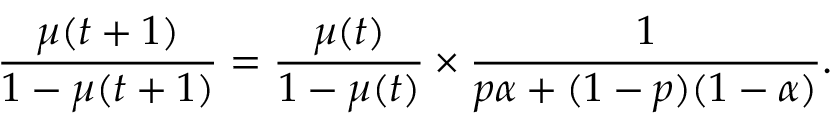<formula> <loc_0><loc_0><loc_500><loc_500>\frac { \mu ( t + 1 ) } { 1 - \mu ( t + 1 ) } = \frac { \mu ( t ) } { 1 - \mu ( t ) } \times \frac { 1 } { p \alpha + ( 1 - p ) ( 1 - \alpha ) } .</formula> 